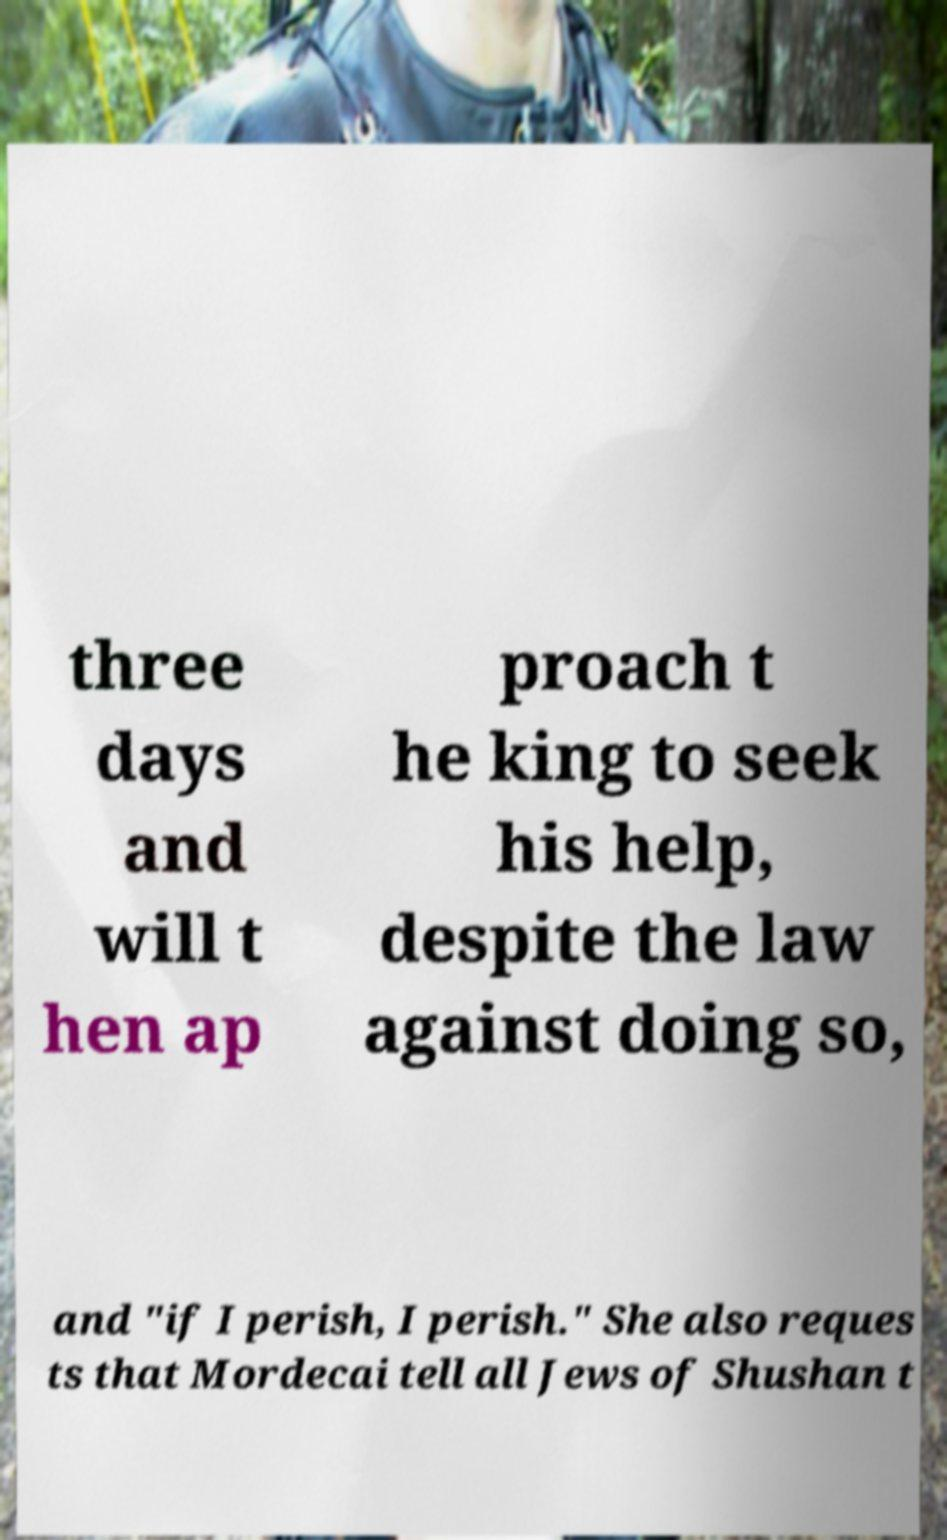Can you accurately transcribe the text from the provided image for me? three days and will t hen ap proach t he king to seek his help, despite the law against doing so, and "if I perish, I perish." She also reques ts that Mordecai tell all Jews of Shushan t 